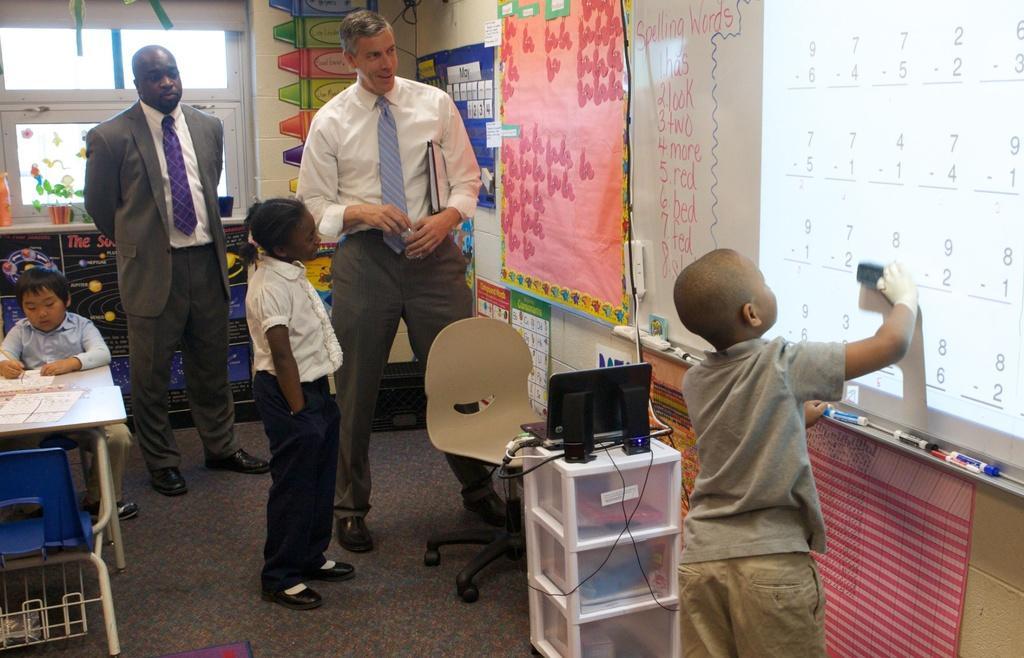How would you summarize this image in a sentence or two? This is an image clicked inside the room. On the left side of the image there is boy sitting on the chair in front of the table. There are two men standing and looking at the screen which is placed on the right side. There is a boy standing in front of the screen. Just beside this boy there is a table. In the background I can see a wall and few sheets are attached to this wall. 